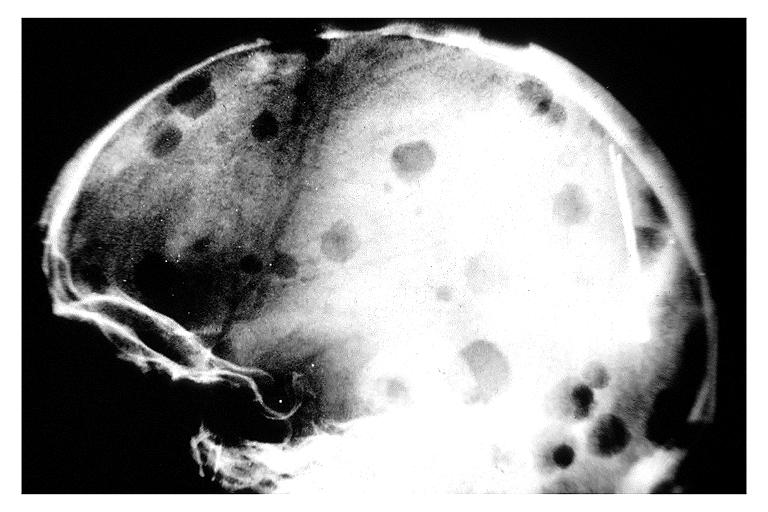s oral present?
Answer the question using a single word or phrase. Yes 